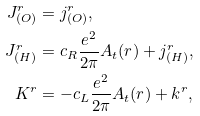<formula> <loc_0><loc_0><loc_500><loc_500>J _ { ( O ) } ^ { r } & = j _ { ( O ) } ^ { r } , \\ J _ { ( H ) } ^ { r } & = c _ { R } \frac { e ^ { 2 } } { 2 \pi } A _ { t } ( r ) + j _ { ( H ) } ^ { r } , \\ K ^ { r } & = - c _ { L } \frac { e ^ { 2 } } { 2 \pi } A _ { t } ( r ) + k ^ { r } ,</formula> 